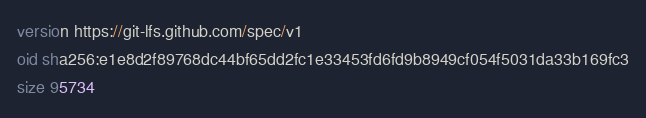Convert code to text. <code><loc_0><loc_0><loc_500><loc_500><_COBOL_>version https://git-lfs.github.com/spec/v1
oid sha256:e1e8d2f89768dc44bf65dd2fc1e33453fd6fd9b8949cf054f5031da33b169fc3
size 95734
</code> 